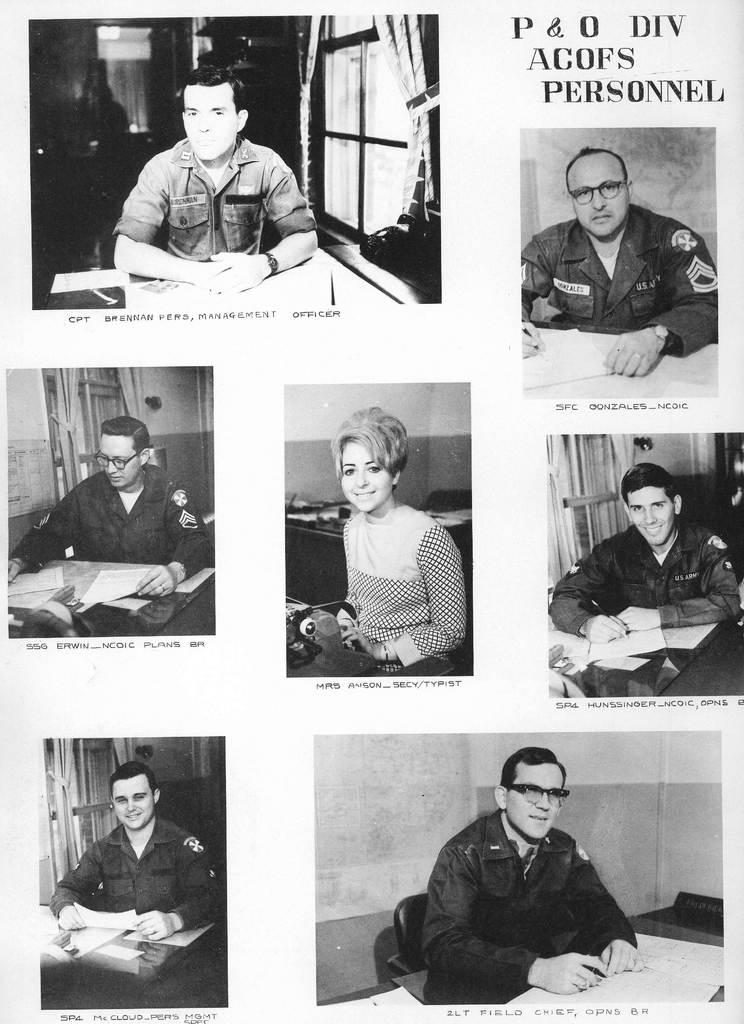What can be seen in the image that features people? There are photos of people in the image. What else is present in the image besides the photos of people? There is text in the image. What type of robin can be seen in the image? There is no robin present in the image; it only features photos of people and text. What kind of structure is visible in the image? There is no structure visible in the image; it only features photos of people and text. 